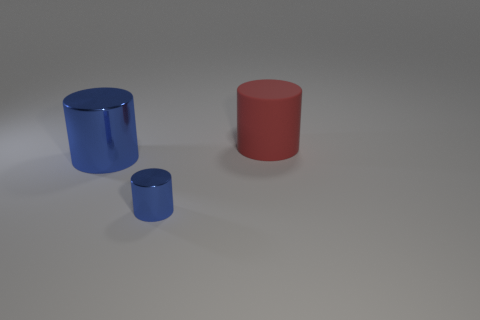Add 2 big blue cylinders. How many objects exist? 5 Add 1 big red matte blocks. How many big red matte blocks exist? 1 Subtract 0 red spheres. How many objects are left? 3 Subtract all big blue cylinders. Subtract all large cyan matte cylinders. How many objects are left? 2 Add 3 rubber things. How many rubber things are left? 4 